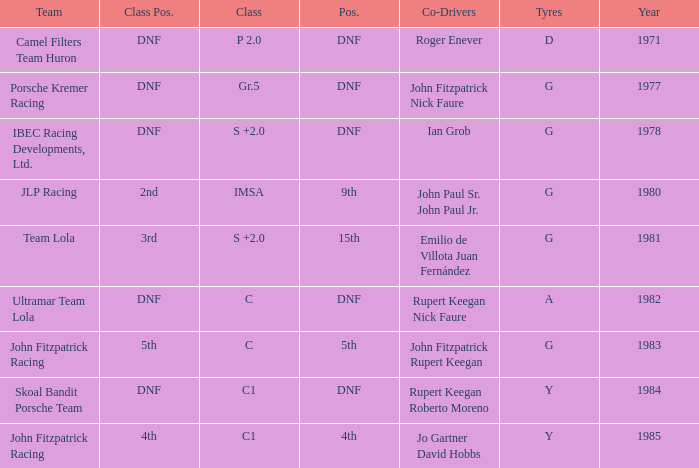Which tires were in Class C in years before 1983? A. 